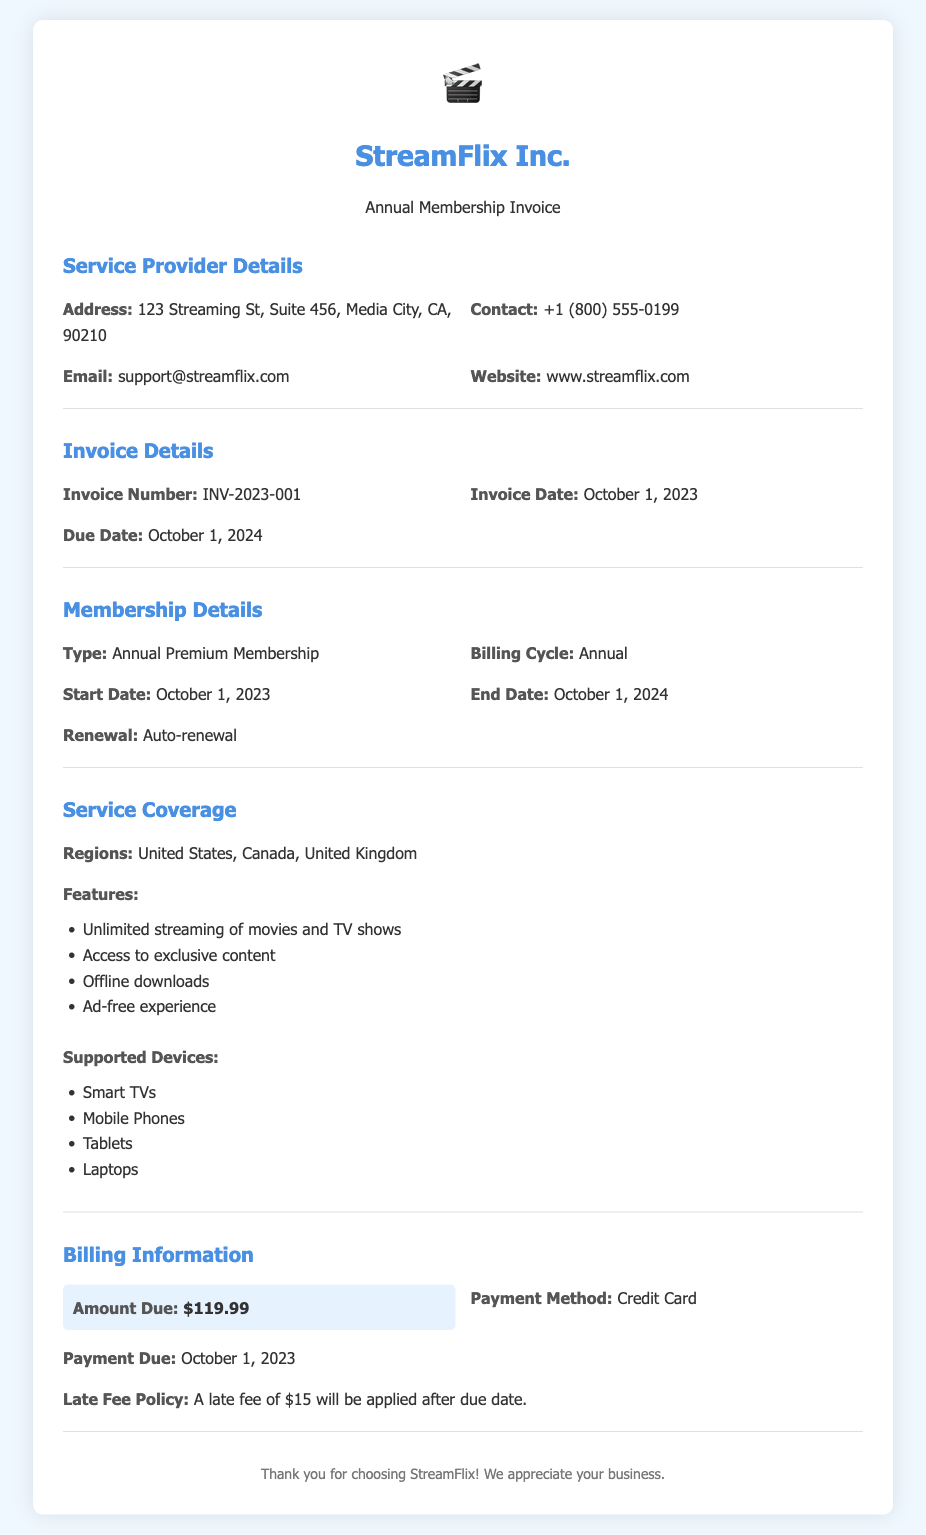What is the invoice number? The invoice number can be found in the Invoice Details section of the document.
Answer: INV-2023-001 What is the amount due? The amount due is mentioned in the Billing Information section of the document.
Answer: $119.99 What is the payment method? The payment method is specified under the Billing Information section.
Answer: Credit Card What is the service start date? The start date for the membership service is listed under Membership Details.
Answer: October 1, 2023 What regions are covered by the service? The regions covered are outlined in the Service Coverage section of the document.
Answer: United States, Canada, United Kingdom What is the late fee amount? The late fee policy is mentioned in the Billing Information section and specifies the fee amount.
Answer: $15 How long is the membership duration? The membership duration is indicated by the start and end date mentioned in the Membership Details section.
Answer: One year What features are included in the service? The features of the membership can be found in the Service Coverage section, listed as a bulleted list.
Answer: Unlimited streaming of movies and TV shows, Access to exclusive content, Offline downloads, Ad-free experience When is the payment due? The due date for the payment is specified in the Billing Information section.
Answer: October 1, 2023 